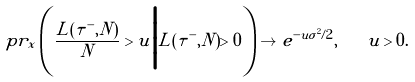<formula> <loc_0><loc_0><loc_500><loc_500>\ p r _ { x } \left ( \frac { L ( \tau ^ { - } , N ) } { N } > u \Big | L ( \tau ^ { - } , N ) > 0 \right ) \to e ^ { - u \sigma ^ { 2 } / 2 } , \quad u > 0 .</formula> 